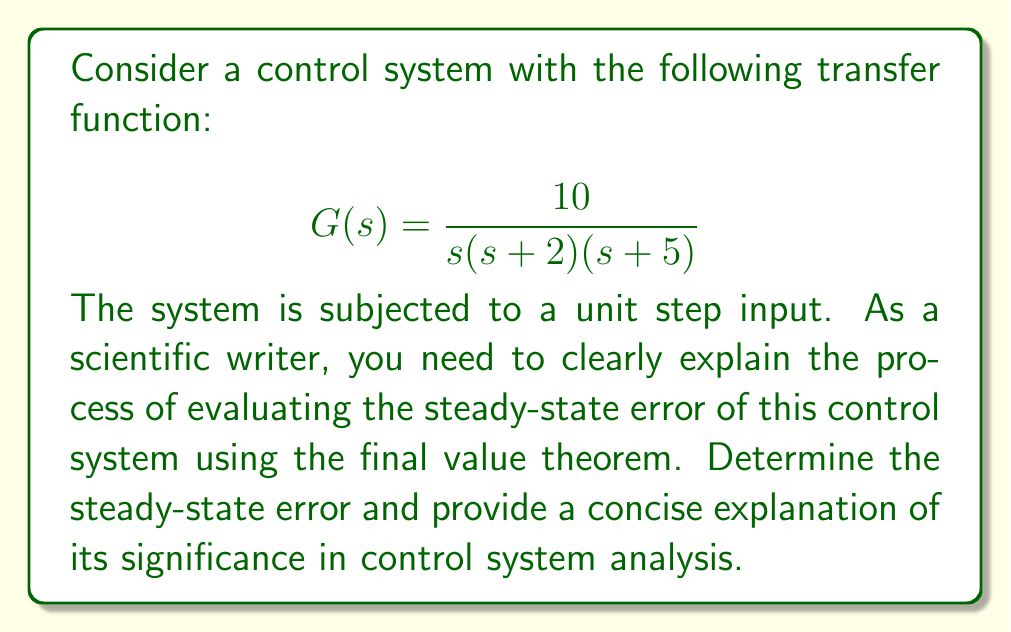Solve this math problem. To evaluate the steady-state error of the given control system using the final value theorem, we follow these steps:

1. Determine the closed-loop transfer function:
   The given transfer function $G(s)$ represents the open-loop transfer function. For a unity feedback system, the closed-loop transfer function is:
   
   $$C(s) = \frac{G(s)}{1 + G(s)}$$

2. Calculate the error transfer function:
   The error transfer function $E(s)$ is given by:
   
   $$E(s) = \frac{1}{1 + G(s)}$$

3. Apply the final value theorem:
   The steady-state error for a step input is given by:
   
   $$e_{ss} = \lim_{s \to 0} sE(s)R(s)$$
   
   where $R(s) = \frac{1}{s}$ for a unit step input.

4. Substitute the expressions:
   
   $$e_{ss} = \lim_{s \to 0} s \cdot \frac{1}{1 + \frac{10}{s(s+2)(s+5)}} \cdot \frac{1}{s}$$

5. Simplify:
   
   $$e_{ss} = \lim_{s \to 0} \frac{s(s+2)(s+5)}{s(s+2)(s+5) + 10}$$

6. Evaluate the limit:
   As $s$ approaches 0, the numerator approaches 0, while the denominator approaches 10.
   
   $$e_{ss} = \frac{0}{10} = 0$$

The steady-state error is zero, indicating that the system will eventually reach the desired setpoint without any persistent offset. This result is significant in control system analysis as it demonstrates that the system has infinite DC gain, which is characteristic of systems with integral action (type 1 or higher).
Answer: The steady-state error of the given control system is 0. 